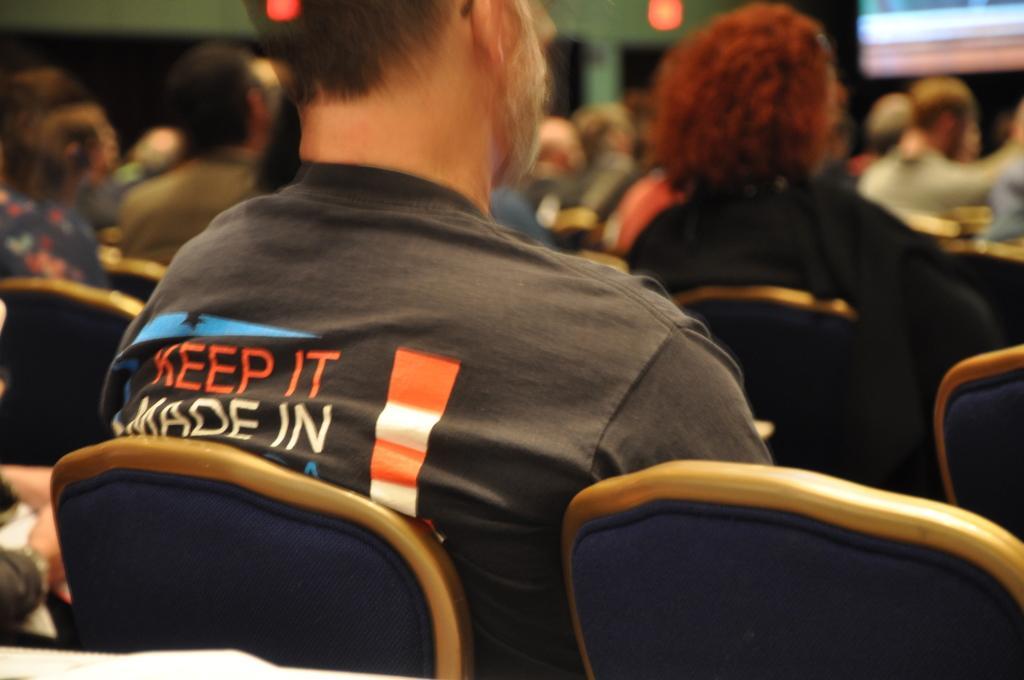Could you give a brief overview of what you see in this image? In this picture we can see all the persons sitting on chairs. This is a wall and door. On the background we can see a partial part of a screen and it seems like a light. 